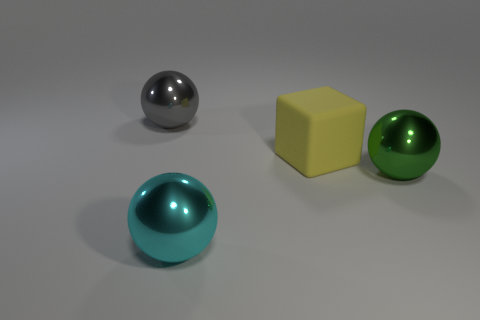Subtract all gray metal balls. How many balls are left? 2 Subtract all cyan spheres. How many spheres are left? 2 Subtract all cubes. How many objects are left? 3 Subtract 1 spheres. How many spheres are left? 2 Add 2 gray spheres. How many objects exist? 6 Subtract 0 gray cylinders. How many objects are left? 4 Subtract all yellow balls. Subtract all blue cylinders. How many balls are left? 3 Subtract all red cylinders. How many green spheres are left? 1 Subtract all large spheres. Subtract all yellow rubber things. How many objects are left? 0 Add 2 big green shiny objects. How many big green shiny objects are left? 3 